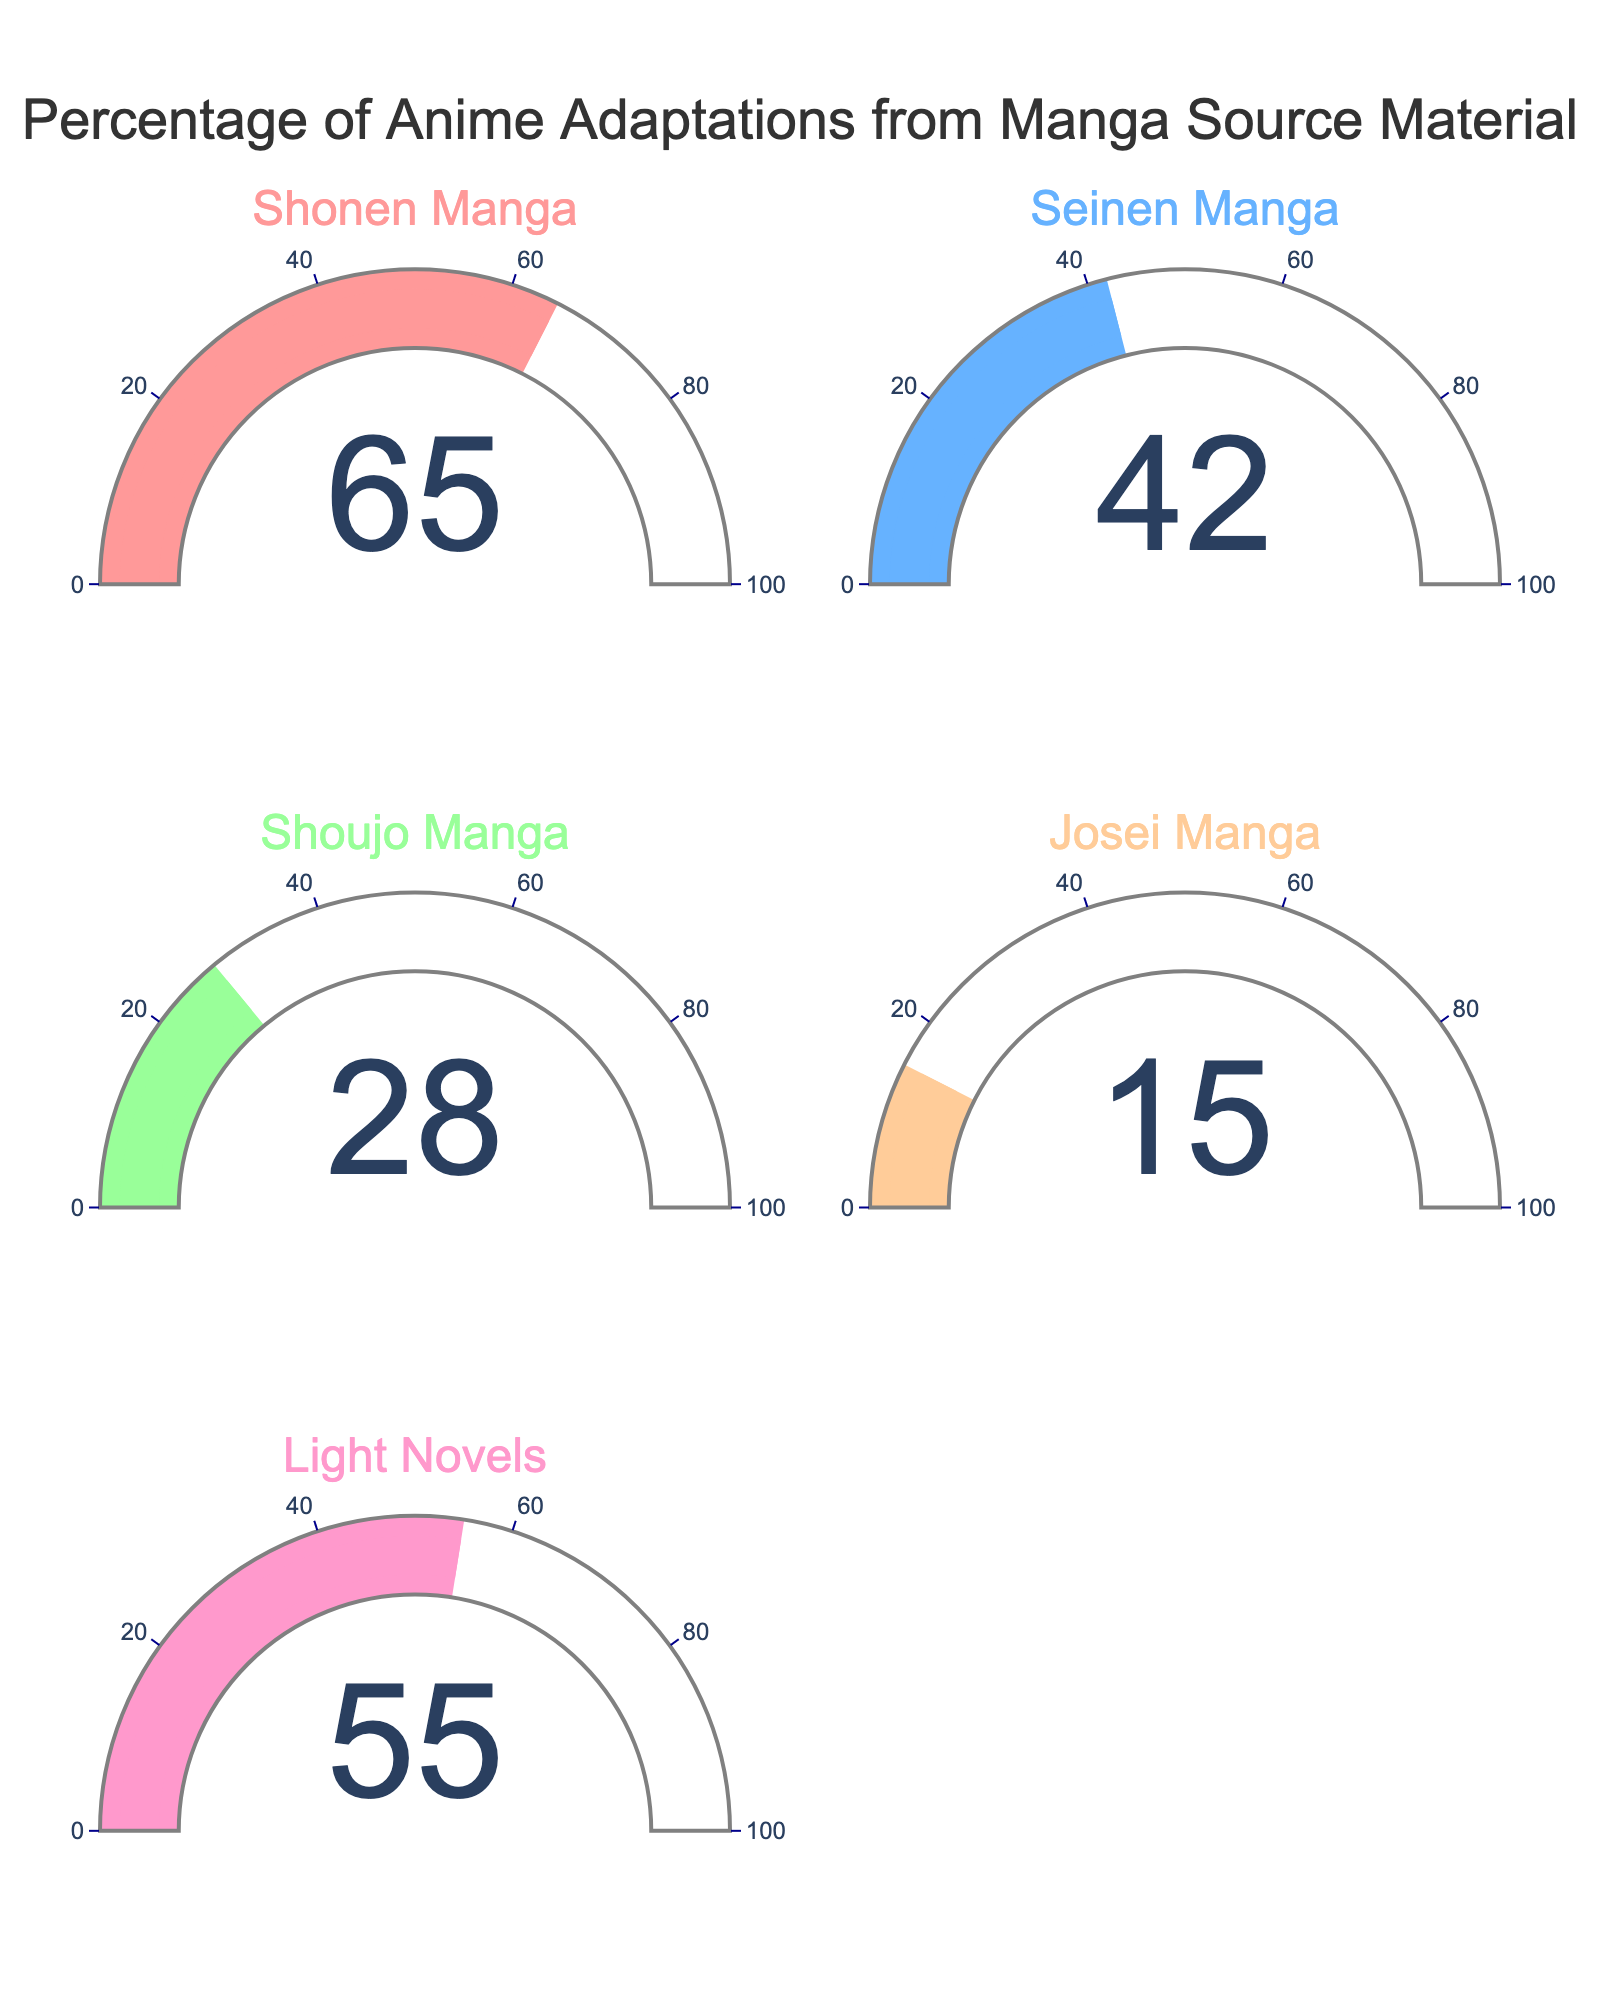What's the percentage of anime adaptations from Shonen Manga? Look for the gauge with the title “Shonen Manga” and note the number indicated near the center of the gauge. The percentage displayed is the required answer.
Answer: 65 Which category has the lowest percentage of anime adaptations from manga source material? Compare the numerical values displayed in the center of each gauge to determine which is the lowest. The gauge labeled “Josei Manga” has the lowest value at 15%.
Answer: Josei Manga What is the average percentage of anime adaptations from Shonen Manga and Seinen Manga? Identify the percentages for Shonen Manga and Seinen Manga from the gauges (65 and 42 respectively). Sum these values and divide by 2 to find the average: (65 + 42) / 2 = 53.5.
Answer: 53.5 Which category is closer to having half its content adapted into anime, Light Novels or Shoujo Manga? Compare the percentages for Light Novels (55) and Shoujo Manga (28). Since 55 is closer to 50 than 28, Light Novels is closer to having half its content adapted into anime.
Answer: Light Novels What is the difference in percentage between Shonen Manga and Josei Manga? Subtract the value of Josei Manga from Shonen Manga: 65 - 15 = 50. The difference is 50%.
Answer: 50 How many categories are displayed in the gauge chart? Count the number of unique gauge indicators in the figure. There are five: Shonen Manga, Seinen Manga, Shoujo Manga, Josei Manga, and Light Novels.
Answer: 5 Which category's gauge has a bar color that is the lightest shade among all? Observing the colors, the lightest shade among all the gauges corresponds to the gauge category. The lightest color is generally pale pink used for "Josei Manga".
Answer: Josei Manga 